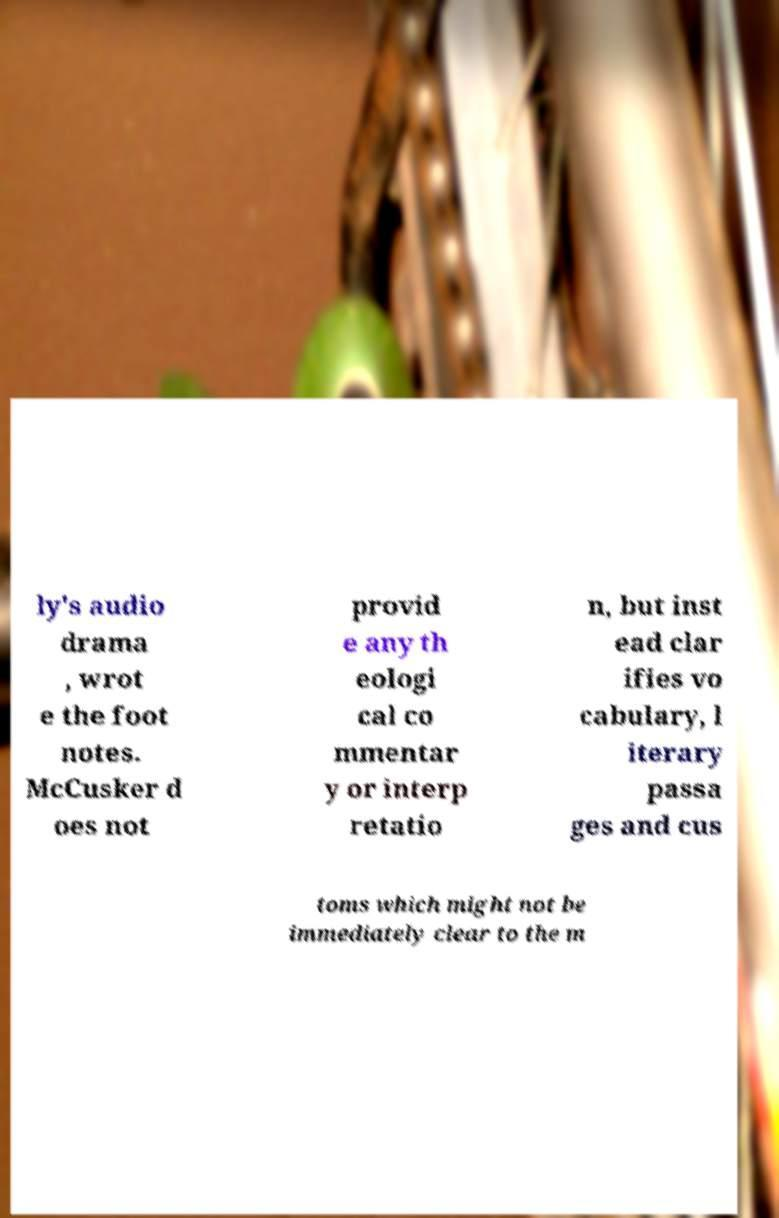For documentation purposes, I need the text within this image transcribed. Could you provide that? ly's audio drama , wrot e the foot notes. McCusker d oes not provid e any th eologi cal co mmentar y or interp retatio n, but inst ead clar ifies vo cabulary, l iterary passa ges and cus toms which might not be immediately clear to the m 